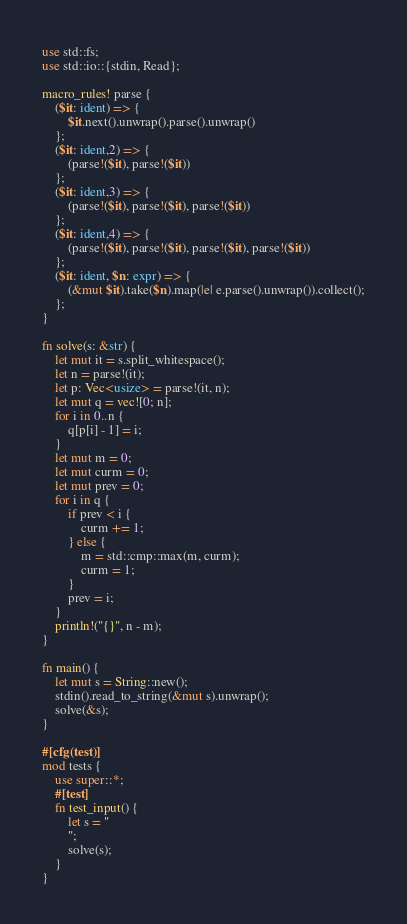<code> <loc_0><loc_0><loc_500><loc_500><_Rust_>use std::fs;
use std::io::{stdin, Read};

macro_rules! parse {
    ($it: ident) => {
        $it.next().unwrap().parse().unwrap()
    };
    ($it: ident,2) => {
        (parse!($it), parse!($it))
    };
    ($it: ident,3) => {
        (parse!($it), parse!($it), parse!($it))
    };
    ($it: ident,4) => {
        (parse!($it), parse!($it), parse!($it), parse!($it))
    };
    ($it: ident, $n: expr) => {
        (&mut $it).take($n).map(|e| e.parse().unwrap()).collect();
    };
}

fn solve(s: &str) {
    let mut it = s.split_whitespace();
    let n = parse!(it);
    let p: Vec<usize> = parse!(it, n);
    let mut q = vec![0; n];
    for i in 0..n {
        q[p[i] - 1] = i;
    }
    let mut m = 0;
    let mut curm = 0;
    let mut prev = 0;
    for i in q {
        if prev < i {
            curm += 1;
        } else {
            m = std::cmp::max(m, curm);
            curm = 1;
        }
        prev = i;
    }
    println!("{}", n - m);
}

fn main() {
    let mut s = String::new();
    stdin().read_to_string(&mut s).unwrap();
    solve(&s);
}

#[cfg(test)]
mod tests {
    use super::*;
    #[test]
    fn test_input() {
        let s = "
        ";
        solve(s);
    }
}
</code> 